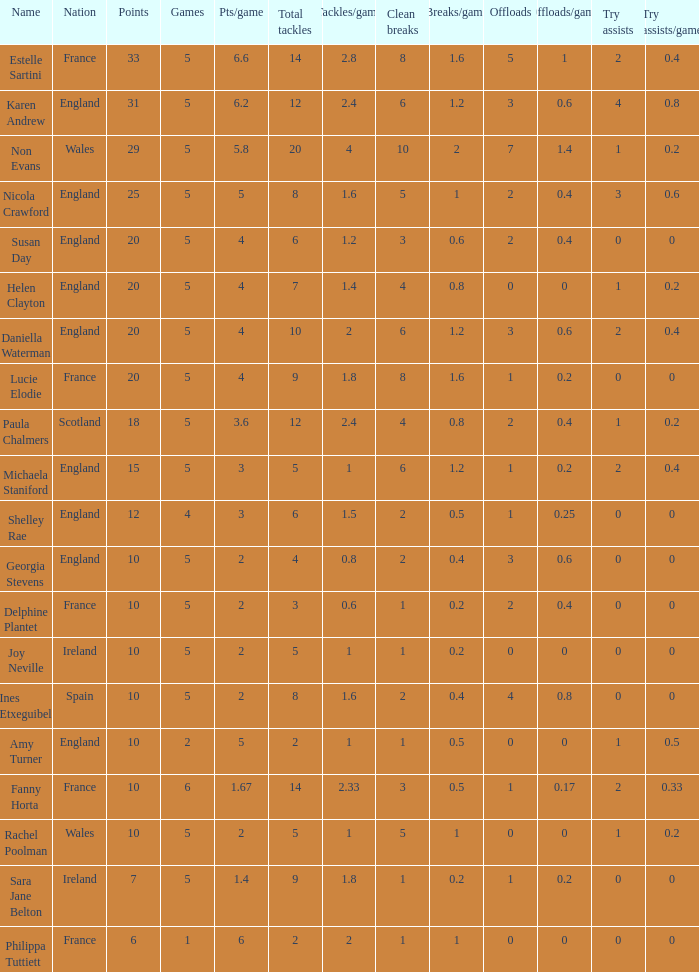Can you tell me the lowest Games that has the Pts/game larger than 1.4 and the Points of 20, and the Name of susan day? 5.0. 